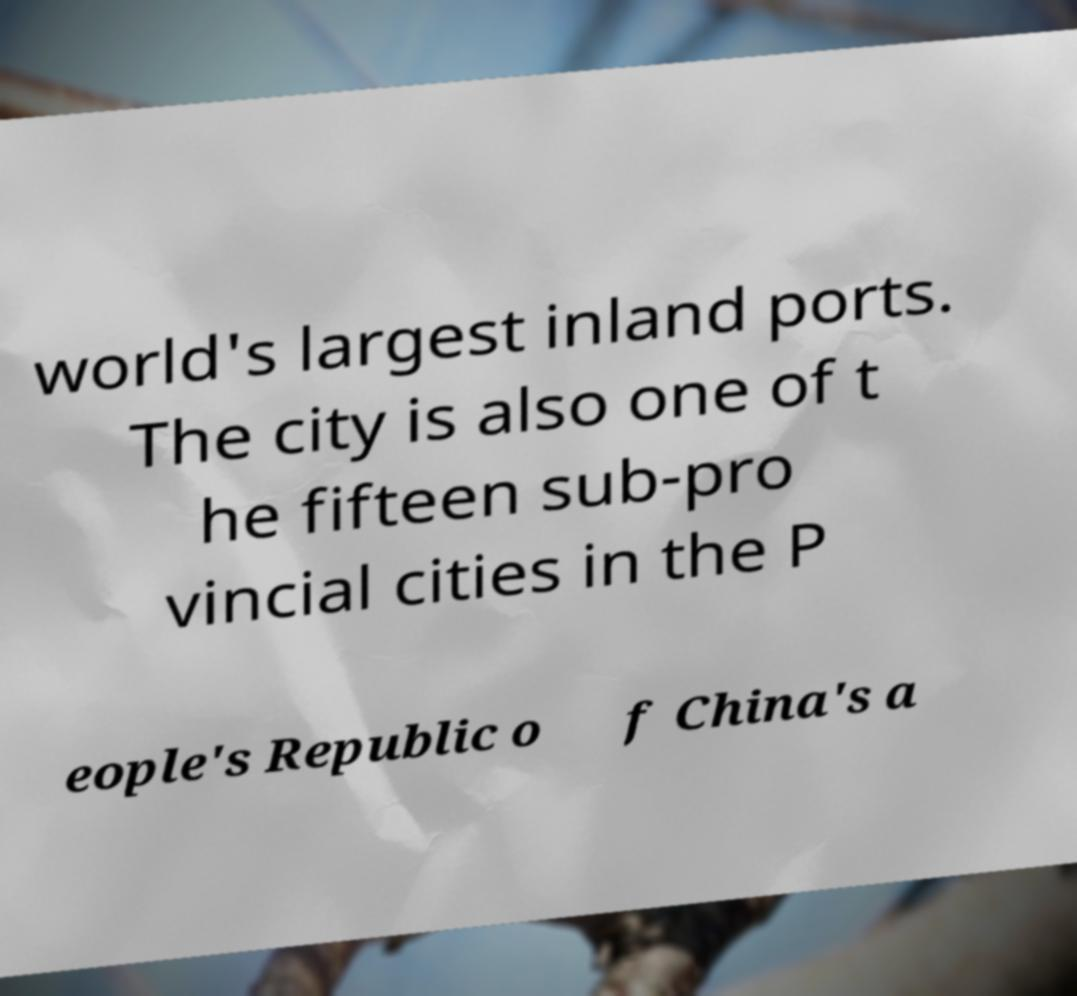There's text embedded in this image that I need extracted. Can you transcribe it verbatim? world's largest inland ports. The city is also one of t he fifteen sub-pro vincial cities in the P eople's Republic o f China's a 